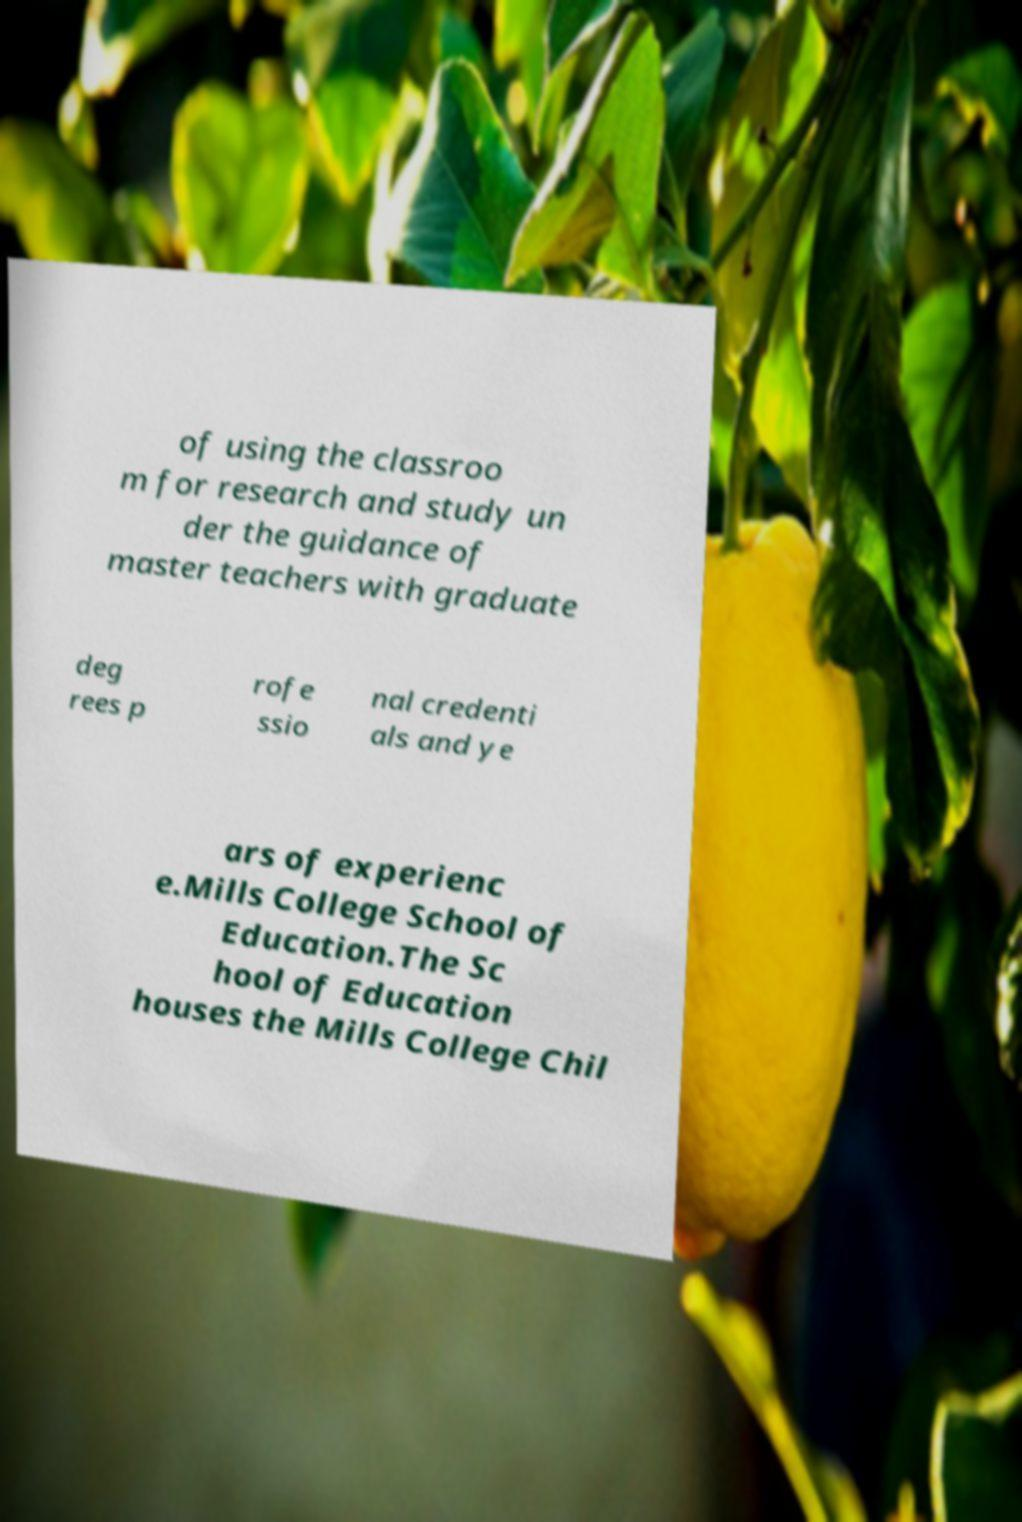For documentation purposes, I need the text within this image transcribed. Could you provide that? of using the classroo m for research and study un der the guidance of master teachers with graduate deg rees p rofe ssio nal credenti als and ye ars of experienc e.Mills College School of Education.The Sc hool of Education houses the Mills College Chil 